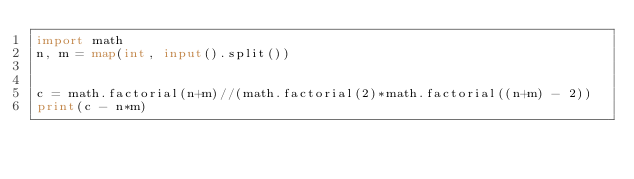Convert code to text. <code><loc_0><loc_0><loc_500><loc_500><_Python_>import math
n, m = map(int, input().split())


c = math.factorial(n+m)//(math.factorial(2)*math.factorial((n+m) - 2))
print(c - n*m)
</code> 